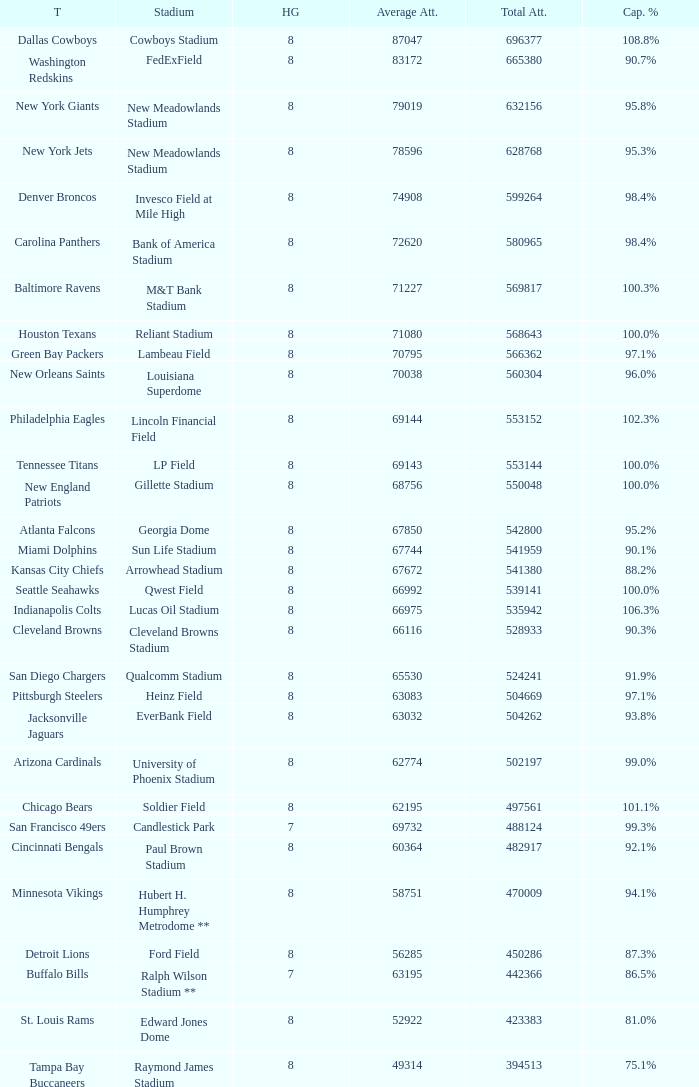What was the capacity percentage when attendance was 71080? 100.0%. 